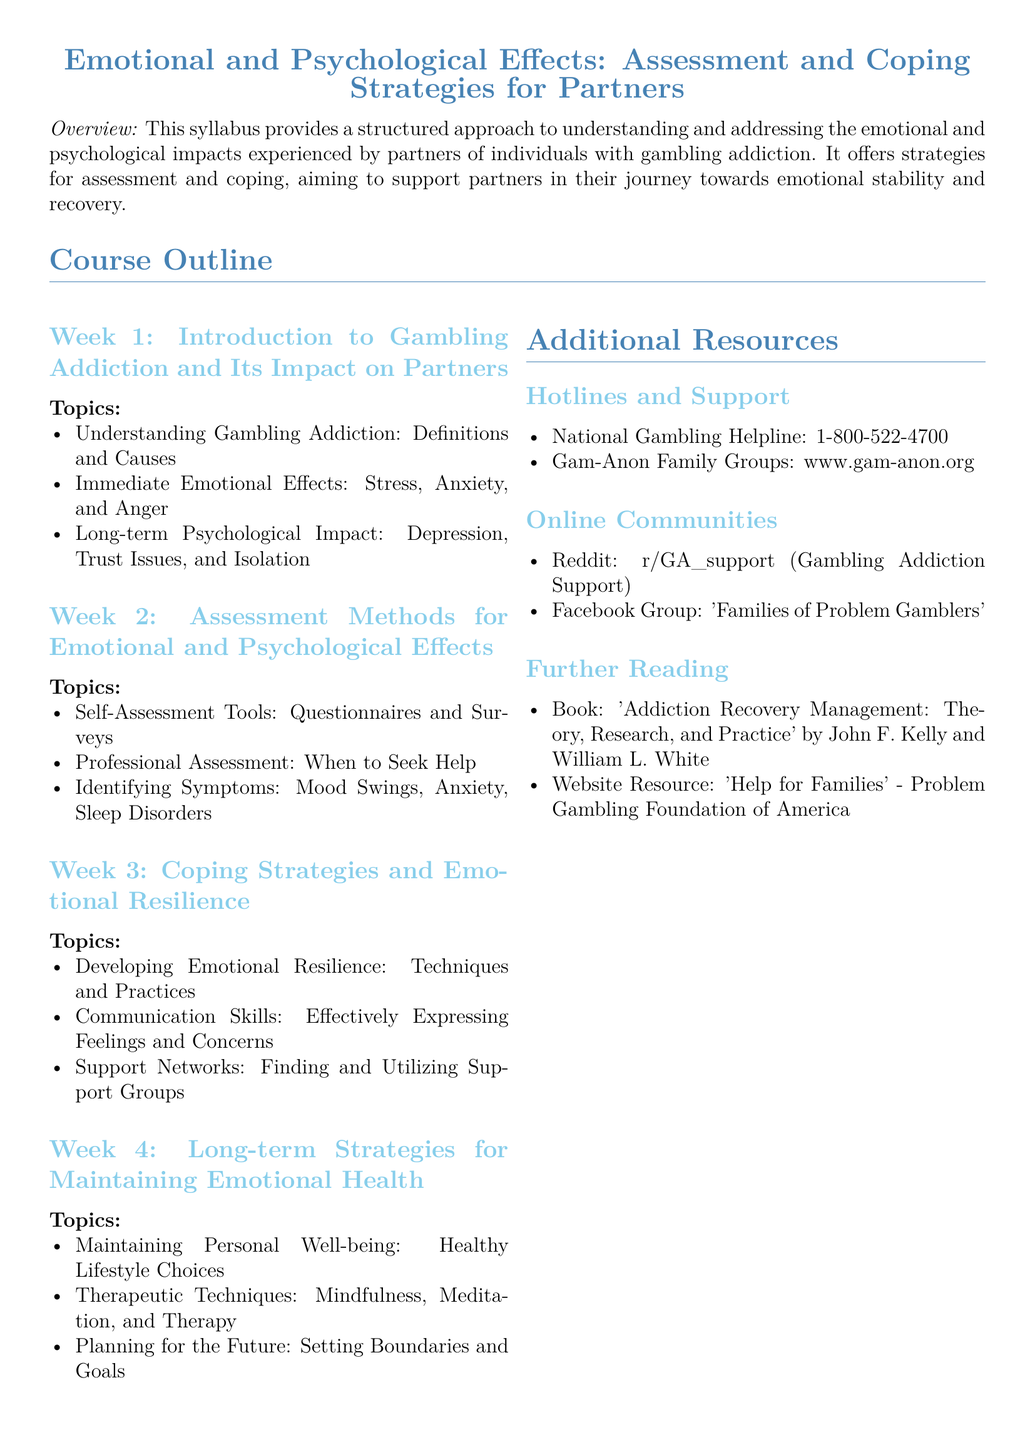What is the title of the syllabus? The title of the syllabus is located at the beginning of the document and states the main focus of the course.
Answer: Emotional and Psychological Effects: Assessment and Coping Strategies for Partners What is the hotline number for the National Gambling Helpline? The hotline number is listed in the additional resources section of the document under hotlines and support.
Answer: 1-800-522-4700 What is discussed in Week 2 of the course outline? Week 2 covers assessment methods for emotional and psychological effects, focusing on self-assessment tools and professional help.
Answer: Assessment Methods for Emotional and Psychological Effects How many weeks are outlined in the course? The document specifies a structured approach divided into four weeks of content for better understanding and coping strategies.
Answer: Four weeks What resource is provided for online community support? The document lists specific online communities that partners can turn to for support, which is included in the additional resources section.
Answer: Reddit: r/GA_support What is one of the therapeutic techniques mentioned in Week 4? Week 4 includes various methods for maintaining emotional health, specifically highlighting certain therapeutic practices.
Answer: Mindfulness What is the primary goal of the syllabus? The goal focuses on understanding emotional and psychological impacts, offering assistance and coping strategies for partners affected by gambling addiction.
Answer: Support partners in their journey towards emotional stability and recovery What is the main color used for headings in the document? The color format for headings is defined at the beginning of the document, relating to the visual structure of the syllabus.
Answer: RGB(70,130,180) 